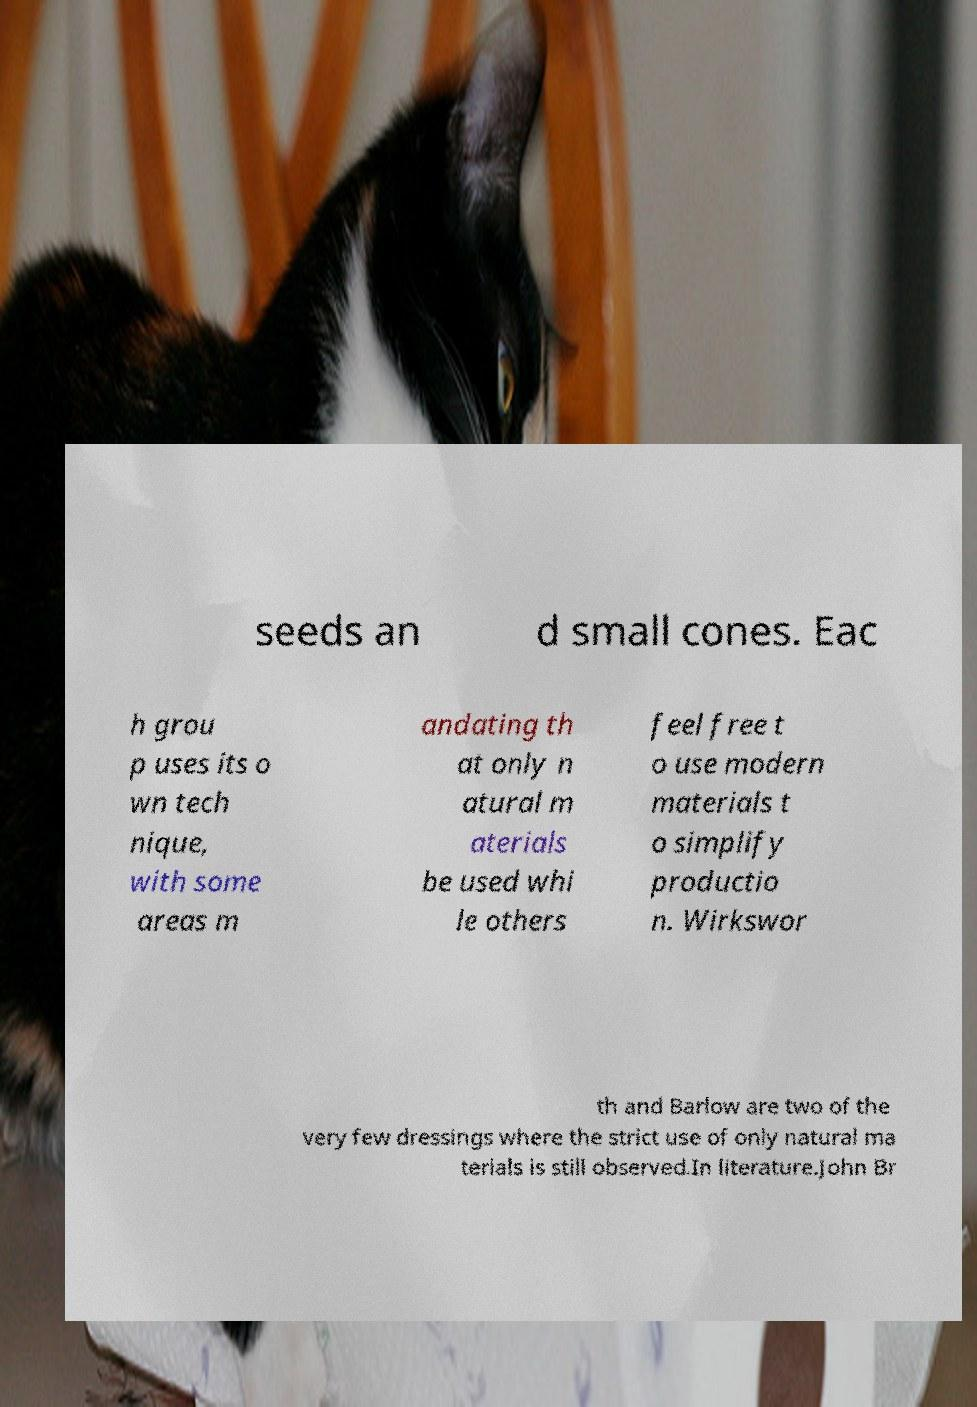Could you assist in decoding the text presented in this image and type it out clearly? seeds an d small cones. Eac h grou p uses its o wn tech nique, with some areas m andating th at only n atural m aterials be used whi le others feel free t o use modern materials t o simplify productio n. Wirkswor th and Barlow are two of the very few dressings where the strict use of only natural ma terials is still observed.In literature.John Br 